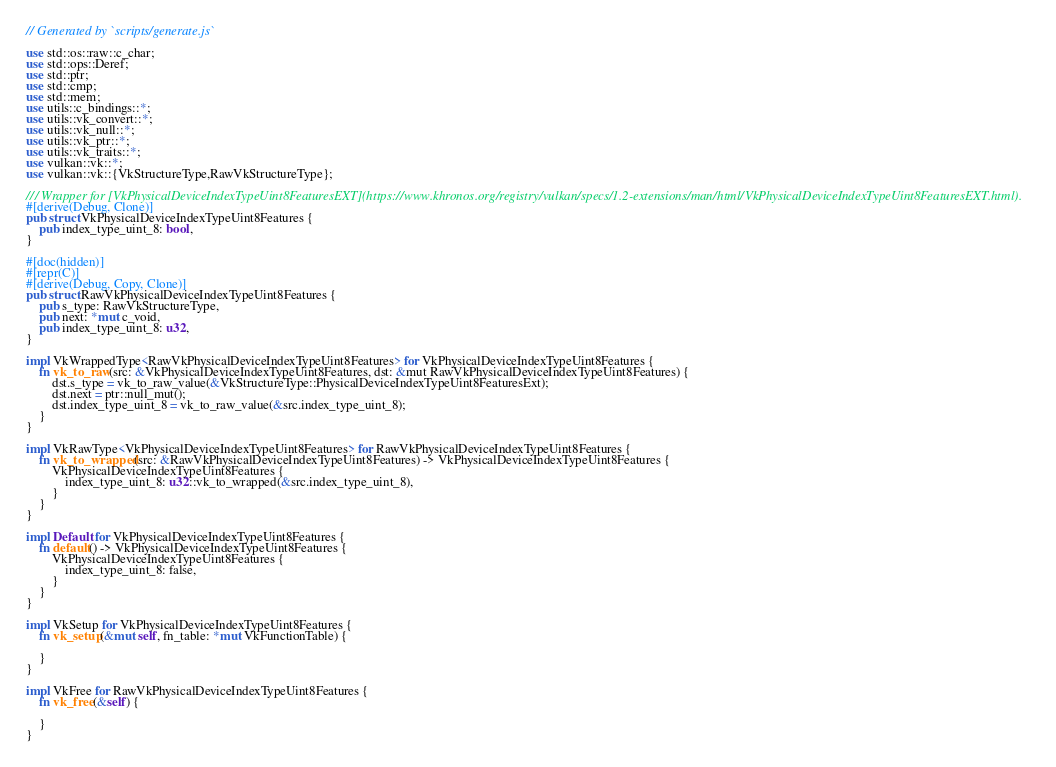<code> <loc_0><loc_0><loc_500><loc_500><_Rust_>// Generated by `scripts/generate.js`

use std::os::raw::c_char;
use std::ops::Deref;
use std::ptr;
use std::cmp;
use std::mem;
use utils::c_bindings::*;
use utils::vk_convert::*;
use utils::vk_null::*;
use utils::vk_ptr::*;
use utils::vk_traits::*;
use vulkan::vk::*;
use vulkan::vk::{VkStructureType,RawVkStructureType};

/// Wrapper for [VkPhysicalDeviceIndexTypeUint8FeaturesEXT](https://www.khronos.org/registry/vulkan/specs/1.2-extensions/man/html/VkPhysicalDeviceIndexTypeUint8FeaturesEXT.html).
#[derive(Debug, Clone)]
pub struct VkPhysicalDeviceIndexTypeUint8Features {
    pub index_type_uint_8: bool,
}

#[doc(hidden)]
#[repr(C)]
#[derive(Debug, Copy, Clone)]
pub struct RawVkPhysicalDeviceIndexTypeUint8Features {
    pub s_type: RawVkStructureType,
    pub next: *mut c_void,
    pub index_type_uint_8: u32,
}

impl VkWrappedType<RawVkPhysicalDeviceIndexTypeUint8Features> for VkPhysicalDeviceIndexTypeUint8Features {
    fn vk_to_raw(src: &VkPhysicalDeviceIndexTypeUint8Features, dst: &mut RawVkPhysicalDeviceIndexTypeUint8Features) {
        dst.s_type = vk_to_raw_value(&VkStructureType::PhysicalDeviceIndexTypeUint8FeaturesExt);
        dst.next = ptr::null_mut();
        dst.index_type_uint_8 = vk_to_raw_value(&src.index_type_uint_8);
    }
}

impl VkRawType<VkPhysicalDeviceIndexTypeUint8Features> for RawVkPhysicalDeviceIndexTypeUint8Features {
    fn vk_to_wrapped(src: &RawVkPhysicalDeviceIndexTypeUint8Features) -> VkPhysicalDeviceIndexTypeUint8Features {
        VkPhysicalDeviceIndexTypeUint8Features {
            index_type_uint_8: u32::vk_to_wrapped(&src.index_type_uint_8),
        }
    }
}

impl Default for VkPhysicalDeviceIndexTypeUint8Features {
    fn default() -> VkPhysicalDeviceIndexTypeUint8Features {
        VkPhysicalDeviceIndexTypeUint8Features {
            index_type_uint_8: false,
        }
    }
}

impl VkSetup for VkPhysicalDeviceIndexTypeUint8Features {
    fn vk_setup(&mut self, fn_table: *mut VkFunctionTable) {
        
    }
}

impl VkFree for RawVkPhysicalDeviceIndexTypeUint8Features {
    fn vk_free(&self) {
        
    }
}</code> 